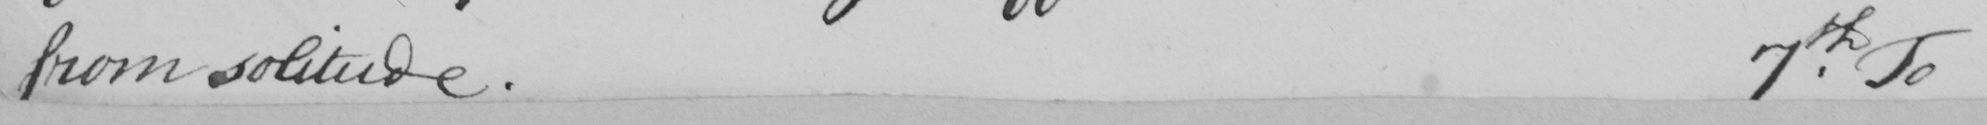Can you tell me what this handwritten text says? from solitude. 7th. To 